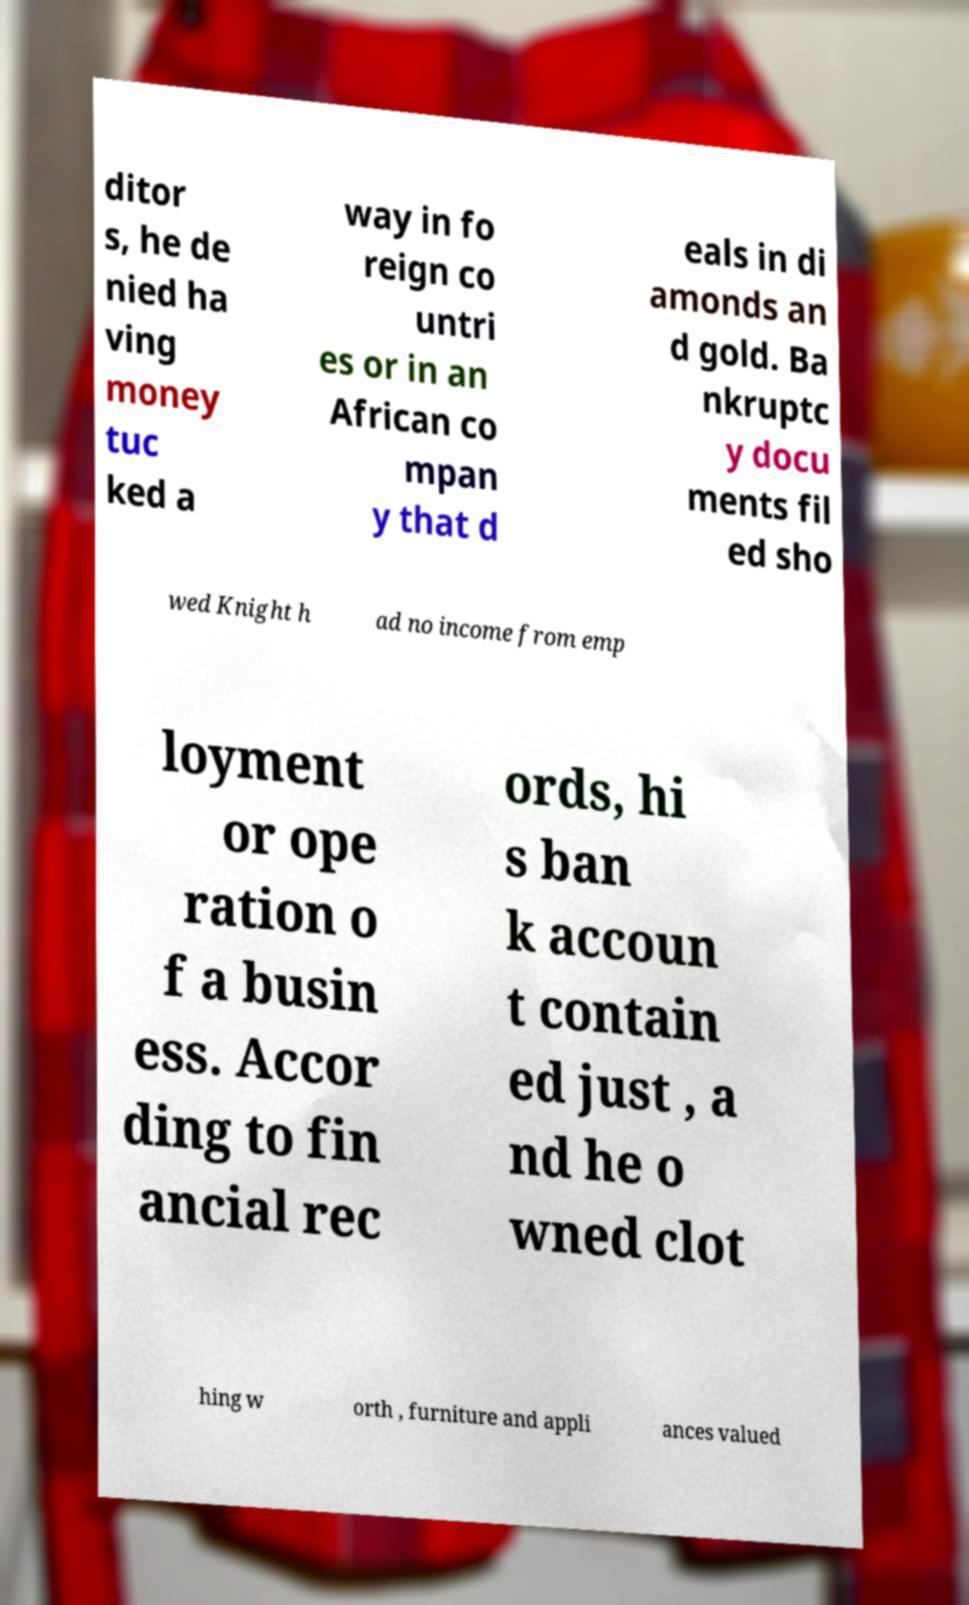What messages or text are displayed in this image? I need them in a readable, typed format. ditor s, he de nied ha ving money tuc ked a way in fo reign co untri es or in an African co mpan y that d eals in di amonds an d gold. Ba nkruptc y docu ments fil ed sho wed Knight h ad no income from emp loyment or ope ration o f a busin ess. Accor ding to fin ancial rec ords, hi s ban k accoun t contain ed just , a nd he o wned clot hing w orth , furniture and appli ances valued 